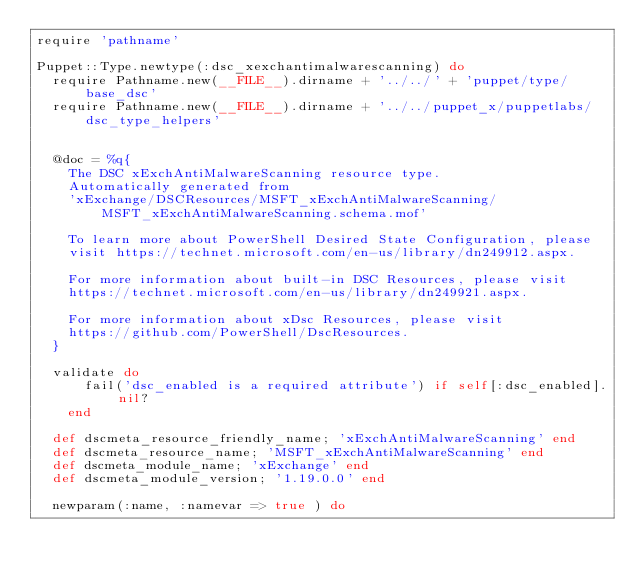Convert code to text. <code><loc_0><loc_0><loc_500><loc_500><_Ruby_>require 'pathname'

Puppet::Type.newtype(:dsc_xexchantimalwarescanning) do
  require Pathname.new(__FILE__).dirname + '../../' + 'puppet/type/base_dsc'
  require Pathname.new(__FILE__).dirname + '../../puppet_x/puppetlabs/dsc_type_helpers'


  @doc = %q{
    The DSC xExchAntiMalwareScanning resource type.
    Automatically generated from
    'xExchange/DSCResources/MSFT_xExchAntiMalwareScanning/MSFT_xExchAntiMalwareScanning.schema.mof'

    To learn more about PowerShell Desired State Configuration, please
    visit https://technet.microsoft.com/en-us/library/dn249912.aspx.

    For more information about built-in DSC Resources, please visit
    https://technet.microsoft.com/en-us/library/dn249921.aspx.

    For more information about xDsc Resources, please visit
    https://github.com/PowerShell/DscResources.
  }

  validate do
      fail('dsc_enabled is a required attribute') if self[:dsc_enabled].nil?
    end

  def dscmeta_resource_friendly_name; 'xExchAntiMalwareScanning' end
  def dscmeta_resource_name; 'MSFT_xExchAntiMalwareScanning' end
  def dscmeta_module_name; 'xExchange' end
  def dscmeta_module_version; '1.19.0.0' end

  newparam(:name, :namevar => true ) do</code> 